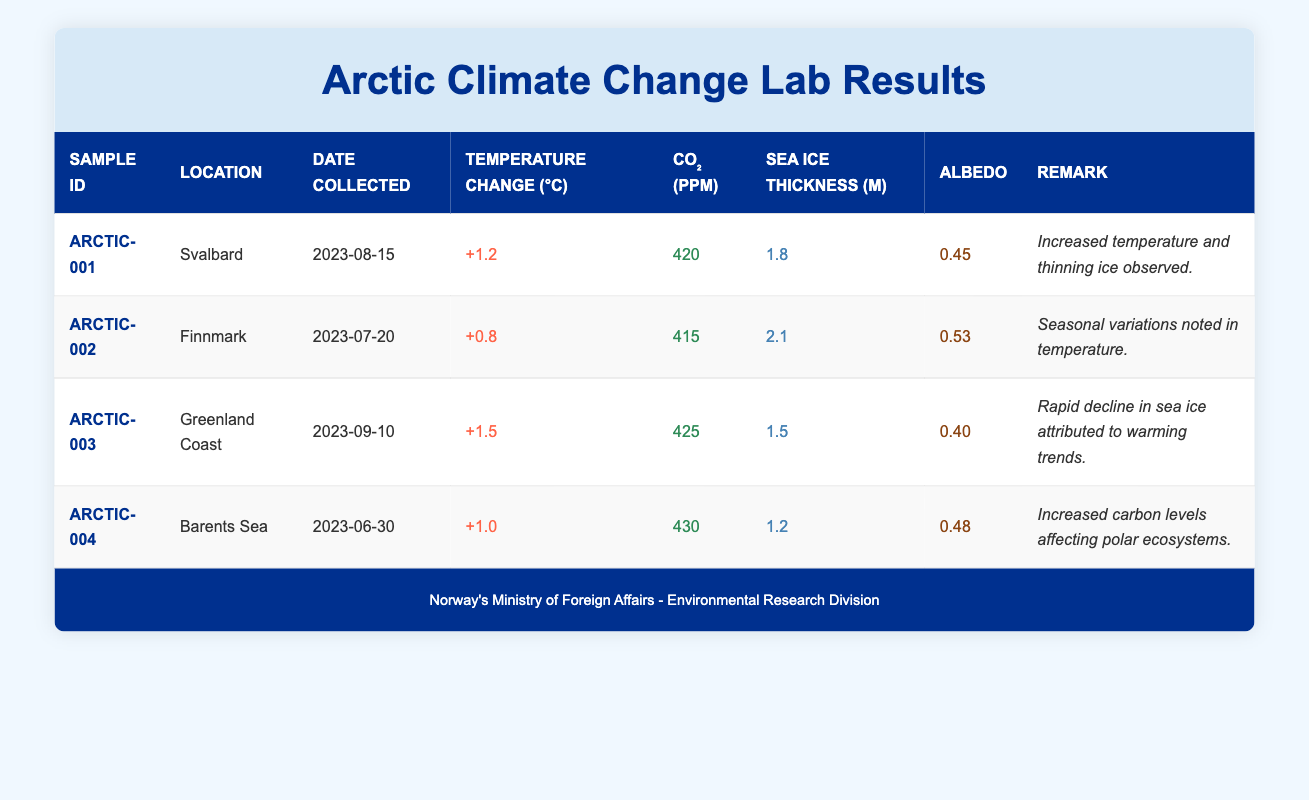What is the temperature change observed at the Greenland Coast? The temperature change for the sample from the Greenland Coast is listed in the table under the "Temperature Change (°C)" column corresponding to sample ID ARCTIC-003, which shows a change of +1.5 degrees Celsius.
Answer: +1.5°C Which location had the highest CO₂ level? By reviewing the CO₂ levels across all locations, we see that the Barents Sea, with a CO₂ level of 430 ppm, has the highest value when compared to 420, 415, and 425 ppm in Svalbard, Finnmark, and the Greenland Coast, respectively.
Answer: Barents Sea What is the average sea ice thickness from the samples collected? To find the average sea ice thickness, sum the thicknesses: 1.8 + 2.1 + 1.5 + 1.2 = 6.6 meters. There are four samples, so the average is 6.6 / 4 = 1.65 meters.
Answer: 1.65 m Was there an increase in temperature in all the locations sampled? When analyzing the temperature changes, all values are greater than 0, showing they all experienced an increase. Specifically, Svalbard has +1.2°C, Finnmark +0.8°C, Greenland Coast +1.5°C, and Barents Sea +1.0°C, confirming an increase in all locations.
Answer: Yes What was the sea ice thickness in Svalbard? The sea ice thickness for the sample collected in Svalbard, as per the table, is recorded to be 1.8 meters.
Answer: 1.8 m Which location exhibited a remark about increased temperature and thinning ice? The remark specifically mentioning "Increased temperature and thinning ice observed" is associated with the sample collected from Svalbard (ARCTIC-001), as indicated by the remarks column in the table.
Answer: Svalbard How many samples were collected from locations with a temperature change of 1°C or higher? The samples with a temperature change of 1°C or greater are Svalbard (+1.2°C), Greenland Coast (+1.5°C), and Barents Sea (+1.0°C), which totals three samples.
Answer: 3 What was the albedo measurement in the sample from Finnmark? The albedo measurement for the sample collected in Finnmark appears in the "Albedo" column for sample ARCTIC-002, indicating a value of 0.53.
Answer: 0.53 Is the albedo measurement from the Greenland Coast higher than that of Svalbard? Comparing the albedo measurements, the Greenland Coast's albedo is 0.40 and Svalbard's is 0.45. Since 0.40 is less than 0.45, the statement is false.
Answer: No 